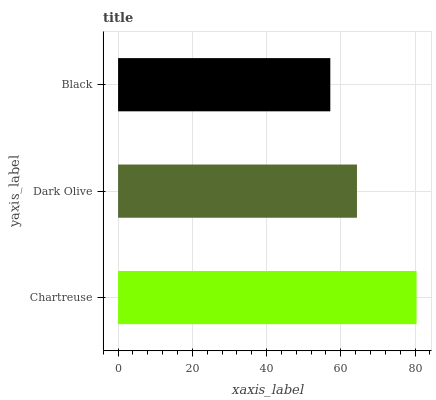Is Black the minimum?
Answer yes or no. Yes. Is Chartreuse the maximum?
Answer yes or no. Yes. Is Dark Olive the minimum?
Answer yes or no. No. Is Dark Olive the maximum?
Answer yes or no. No. Is Chartreuse greater than Dark Olive?
Answer yes or no. Yes. Is Dark Olive less than Chartreuse?
Answer yes or no. Yes. Is Dark Olive greater than Chartreuse?
Answer yes or no. No. Is Chartreuse less than Dark Olive?
Answer yes or no. No. Is Dark Olive the high median?
Answer yes or no. Yes. Is Dark Olive the low median?
Answer yes or no. Yes. Is Black the high median?
Answer yes or no. No. Is Chartreuse the low median?
Answer yes or no. No. 